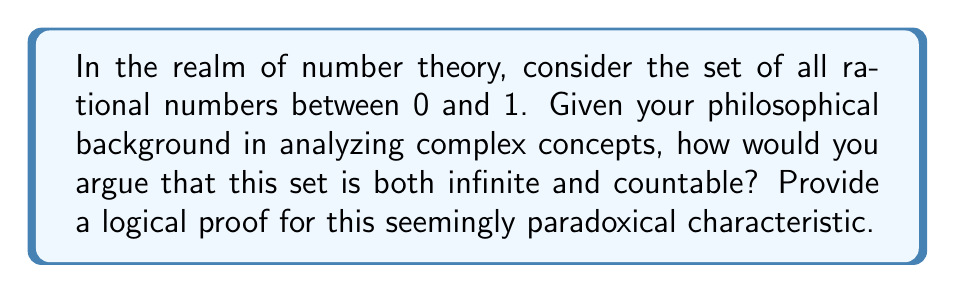Provide a solution to this math problem. To prove that the set of rational numbers between 0 and 1 is both infinite and countable, we can follow these steps:

1. Infinity:
   The set is infinite because we can always find a rational number between any two given rational numbers. For instance, between $\frac{1}{2}$ and $\frac{1}{3}$, we have $\frac{5}{12}$. This process can be continued indefinitely, showing that there are infinitely many rational numbers in this interval.

2. Countability:
   To prove countability, we need to show that we can create a one-to-one correspondence between this set and the set of natural numbers. We can do this using the following method:

   a) Represent each rational number as a fraction $\frac{p}{q}$, where $p$ and $q$ are positive integers and $q > p$ (to ensure the fraction is between 0 and 1).

   b) Arrange these fractions in a 2D grid:

      $$
      \begin{array}{ccccc}
      \frac{1}{2} & \frac{1}{3} & \frac{1}{4} & \frac{1}{5} & \cdots \\
      \frac{2}{3} & \frac{2}{5} & \frac{2}{7} & \frac{2}{9} & \cdots \\
      \frac{3}{4} & \frac{3}{5} & \frac{3}{7} & \frac{3}{8} & \cdots \\
      \frac{4}{5} & \frac{4}{7} & \frac{4}{9} & \frac{4}{11} & \cdots \\
      \vdots & \vdots & \vdots & \vdots & \ddots
      \end{array}
      $$

   c) Now, we can count these fractions using a diagonal zigzag pattern:
      $\frac{1}{2}, \frac{1}{3}, \frac{2}{3}, \frac{1}{4}, \frac{3}{4}, \frac{2}{5}, \frac{1}{5}, \frac{1}{6}, \frac{5}{6}, \frac{4}{5}, \frac{3}{5}, \frac{2}{7}, \frac{1}{7}, \ldots$

   d) This pattern ensures that every rational number in our set will eventually be reached, and each one corresponds to a unique natural number in the order we count them.

3. Removing duplicates:
   Some fractions in this list represent the same rational number (e.g., $\frac{1}{2}$ and $\frac{2}{4}$). We can simply skip these duplicates in our counting process, which doesn't affect the countability of the set.

This proof demonstrates that despite being infinite, the set of rational numbers between 0 and 1 can be put into a one-to-one correspondence with the natural numbers, making it countably infinite.
Answer: The set of rational numbers between 0 and 1 is both infinite and countable. It is infinite because there are infinitely many rational numbers in this interval, and it is countable because we can establish a one-to-one correspondence between this set and the set of natural numbers using a diagonal counting method on a 2D grid of fractions. 